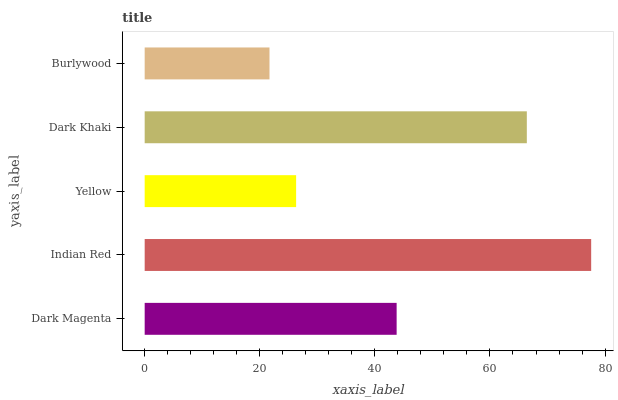Is Burlywood the minimum?
Answer yes or no. Yes. Is Indian Red the maximum?
Answer yes or no. Yes. Is Yellow the minimum?
Answer yes or no. No. Is Yellow the maximum?
Answer yes or no. No. Is Indian Red greater than Yellow?
Answer yes or no. Yes. Is Yellow less than Indian Red?
Answer yes or no. Yes. Is Yellow greater than Indian Red?
Answer yes or no. No. Is Indian Red less than Yellow?
Answer yes or no. No. Is Dark Magenta the high median?
Answer yes or no. Yes. Is Dark Magenta the low median?
Answer yes or no. Yes. Is Dark Khaki the high median?
Answer yes or no. No. Is Yellow the low median?
Answer yes or no. No. 